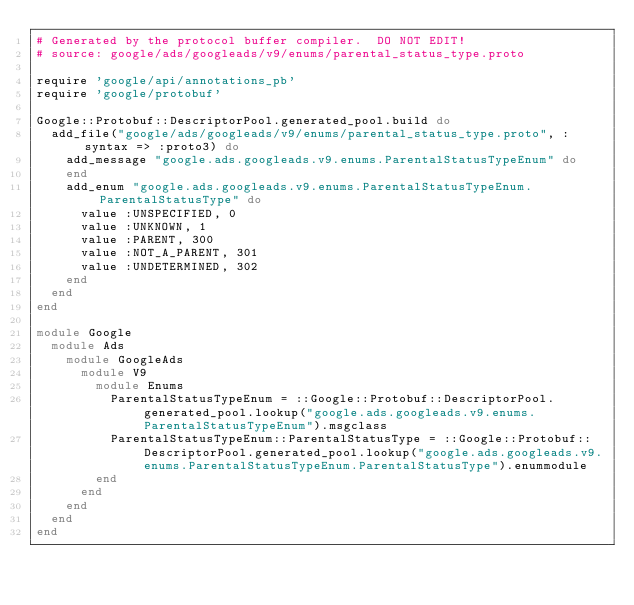<code> <loc_0><loc_0><loc_500><loc_500><_Ruby_># Generated by the protocol buffer compiler.  DO NOT EDIT!
# source: google/ads/googleads/v9/enums/parental_status_type.proto

require 'google/api/annotations_pb'
require 'google/protobuf'

Google::Protobuf::DescriptorPool.generated_pool.build do
  add_file("google/ads/googleads/v9/enums/parental_status_type.proto", :syntax => :proto3) do
    add_message "google.ads.googleads.v9.enums.ParentalStatusTypeEnum" do
    end
    add_enum "google.ads.googleads.v9.enums.ParentalStatusTypeEnum.ParentalStatusType" do
      value :UNSPECIFIED, 0
      value :UNKNOWN, 1
      value :PARENT, 300
      value :NOT_A_PARENT, 301
      value :UNDETERMINED, 302
    end
  end
end

module Google
  module Ads
    module GoogleAds
      module V9
        module Enums
          ParentalStatusTypeEnum = ::Google::Protobuf::DescriptorPool.generated_pool.lookup("google.ads.googleads.v9.enums.ParentalStatusTypeEnum").msgclass
          ParentalStatusTypeEnum::ParentalStatusType = ::Google::Protobuf::DescriptorPool.generated_pool.lookup("google.ads.googleads.v9.enums.ParentalStatusTypeEnum.ParentalStatusType").enummodule
        end
      end
    end
  end
end
</code> 